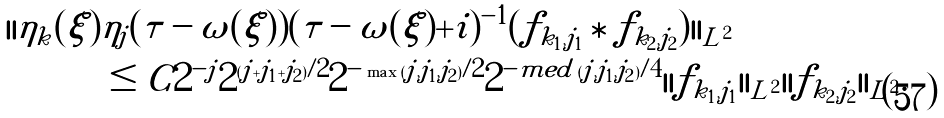Convert formula to latex. <formula><loc_0><loc_0><loc_500><loc_500>| | \eta _ { k } ( \xi ) & \eta _ { j } ( \tau - \omega ( \xi ) ) ( \tau - \omega ( \xi ) + i ) ^ { - 1 } ( f _ { k _ { 1 } , j _ { 1 } } \ast f _ { k _ { 2 } , j _ { 2 } } ) | | _ { L ^ { 2 } } \\ & \leq C 2 ^ { - j } 2 ^ { ( j + j _ { 1 } + j _ { 2 } ) / 2 } 2 ^ { - \max \, ( j , j _ { 1 } , j _ { 2 } ) / 2 } 2 ^ { - m e d \, ( j , j _ { 1 } , j _ { 2 } ) / 4 } | | f _ { k _ { 1 } , j _ { 1 } } | | _ { L ^ { 2 } } | | f _ { k _ { 2 } , j _ { 2 } } | | _ { L ^ { 2 } } .</formula> 